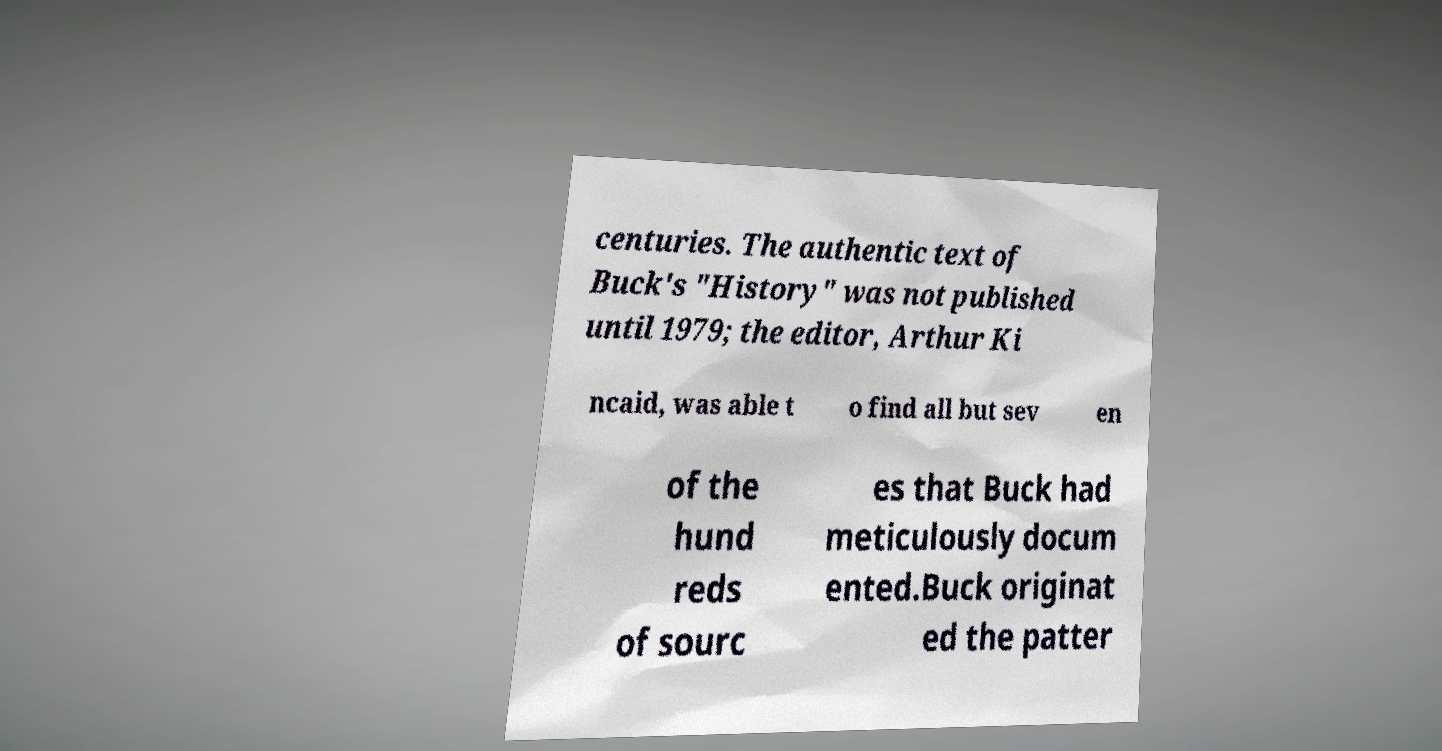Could you extract and type out the text from this image? centuries. The authentic text of Buck's "History" was not published until 1979; the editor, Arthur Ki ncaid, was able t o find all but sev en of the hund reds of sourc es that Buck had meticulously docum ented.Buck originat ed the patter 